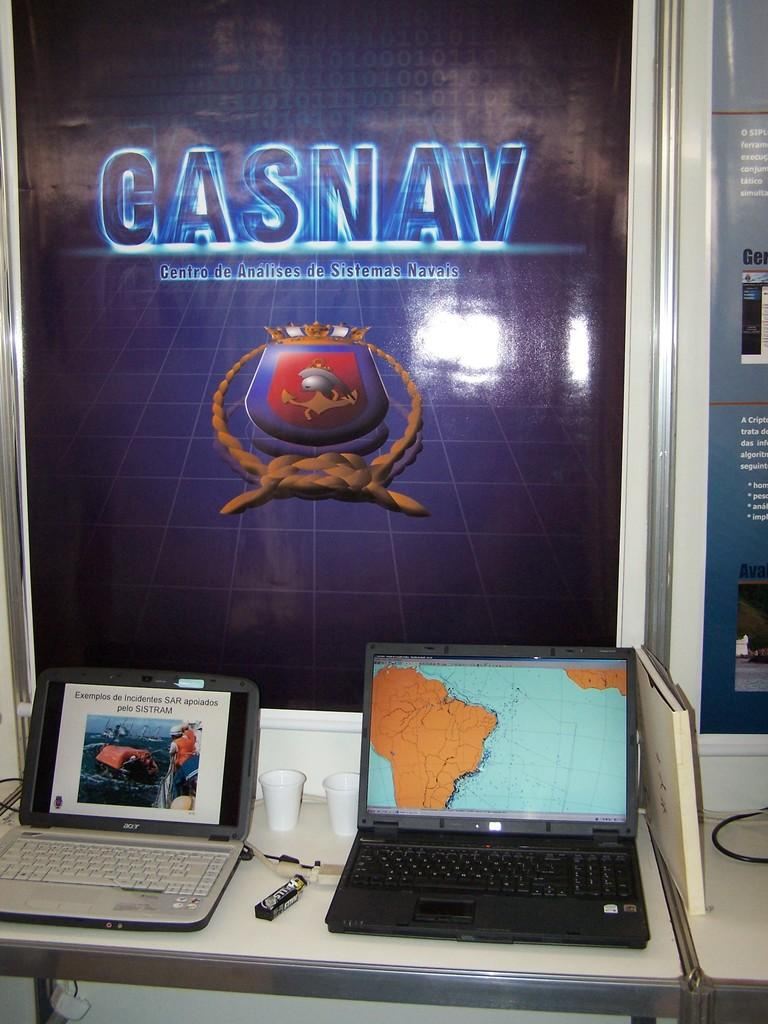<image>
Describe the image concisely. a gasnav poster above two laptops and cups 